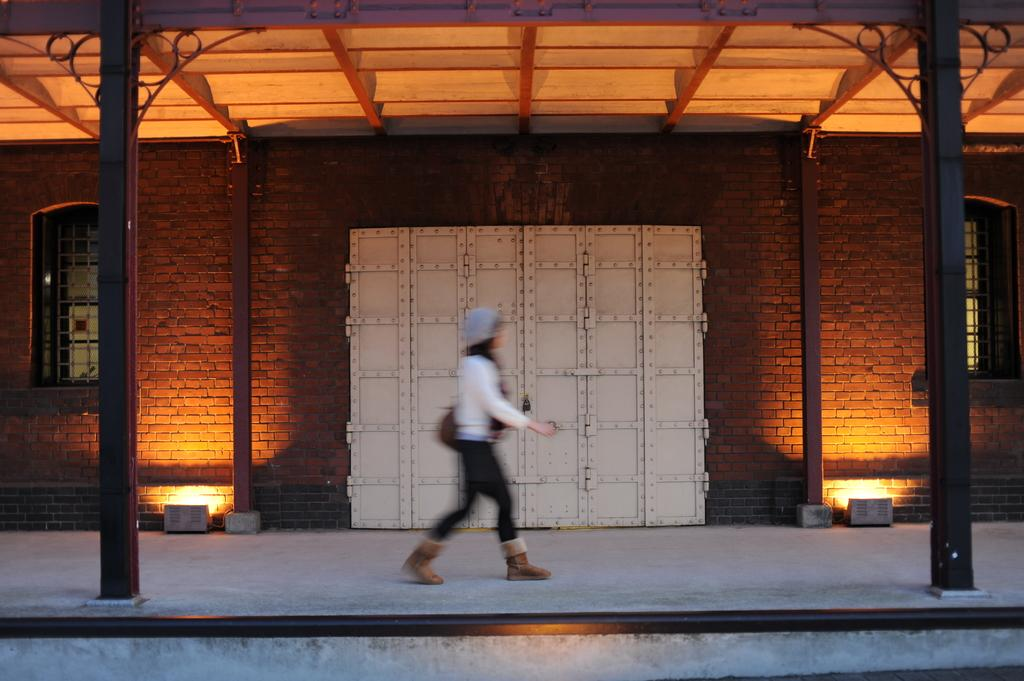What type of structure is visible in the image? There is a building in the image. What material is the door of the building made of? The building has a metal door. Who is present in the image? There is a woman in the image. What is the woman doing in the image? The woman is moving through a corridor. What is the tax rate for the building in the image? There is no information about tax rates in the image, as it only shows a building with a metal door and a woman moving through a corridor. 